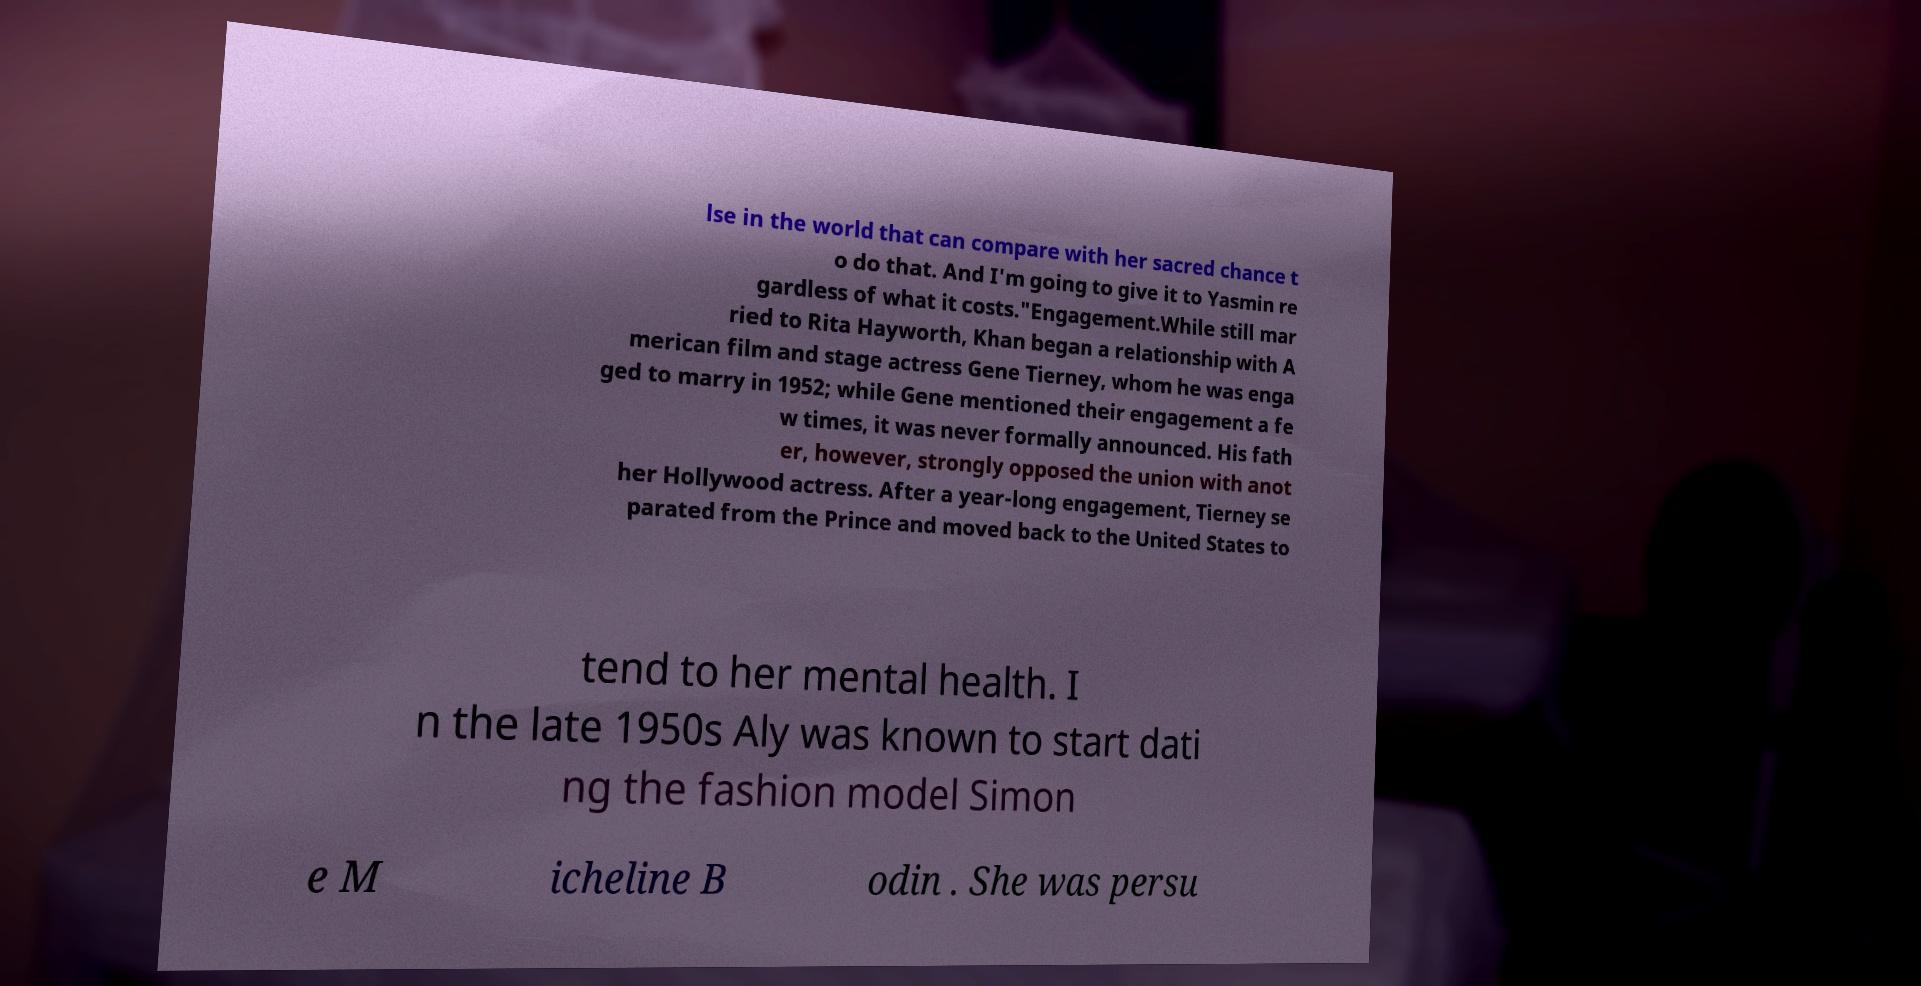What messages or text are displayed in this image? I need them in a readable, typed format. lse in the world that can compare with her sacred chance t o do that. And I'm going to give it to Yasmin re gardless of what it costs."Engagement.While still mar ried to Rita Hayworth, Khan began a relationship with A merican film and stage actress Gene Tierney, whom he was enga ged to marry in 1952; while Gene mentioned their engagement a fe w times, it was never formally announced. His fath er, however, strongly opposed the union with anot her Hollywood actress. After a year-long engagement, Tierney se parated from the Prince and moved back to the United States to tend to her mental health. I n the late 1950s Aly was known to start dati ng the fashion model Simon e M icheline B odin . She was persu 